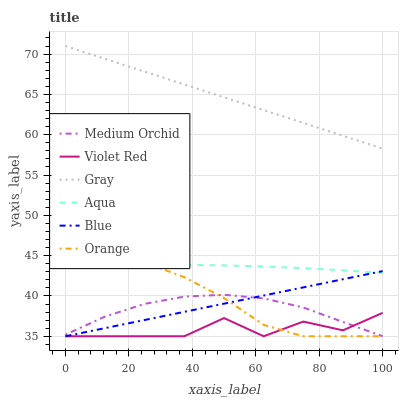Does Violet Red have the minimum area under the curve?
Answer yes or no. Yes. Does Gray have the maximum area under the curve?
Answer yes or no. Yes. Does Gray have the minimum area under the curve?
Answer yes or no. No. Does Violet Red have the maximum area under the curve?
Answer yes or no. No. Is Blue the smoothest?
Answer yes or no. Yes. Is Violet Red the roughest?
Answer yes or no. Yes. Is Gray the smoothest?
Answer yes or no. No. Is Gray the roughest?
Answer yes or no. No. Does Blue have the lowest value?
Answer yes or no. Yes. Does Gray have the lowest value?
Answer yes or no. No. Does Gray have the highest value?
Answer yes or no. Yes. Does Violet Red have the highest value?
Answer yes or no. No. Is Blue less than Gray?
Answer yes or no. Yes. Is Aqua greater than Violet Red?
Answer yes or no. Yes. Does Orange intersect Violet Red?
Answer yes or no. Yes. Is Orange less than Violet Red?
Answer yes or no. No. Is Orange greater than Violet Red?
Answer yes or no. No. Does Blue intersect Gray?
Answer yes or no. No. 